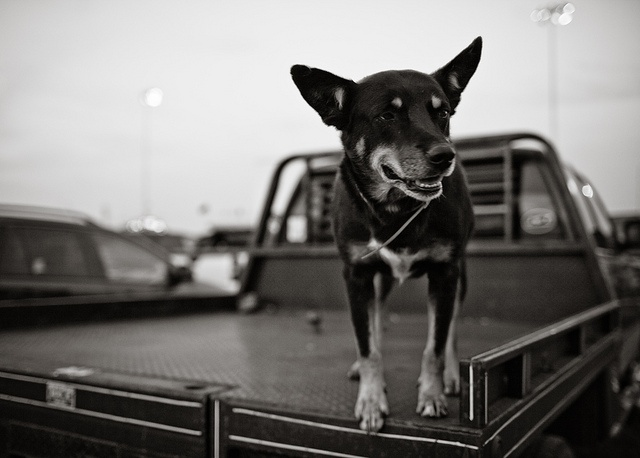Describe the objects in this image and their specific colors. I can see truck in darkgray, black, and gray tones, dog in darkgray, black, and gray tones, truck in darkgray, black, and gray tones, and truck in darkgray, gray, black, and lightgray tones in this image. 